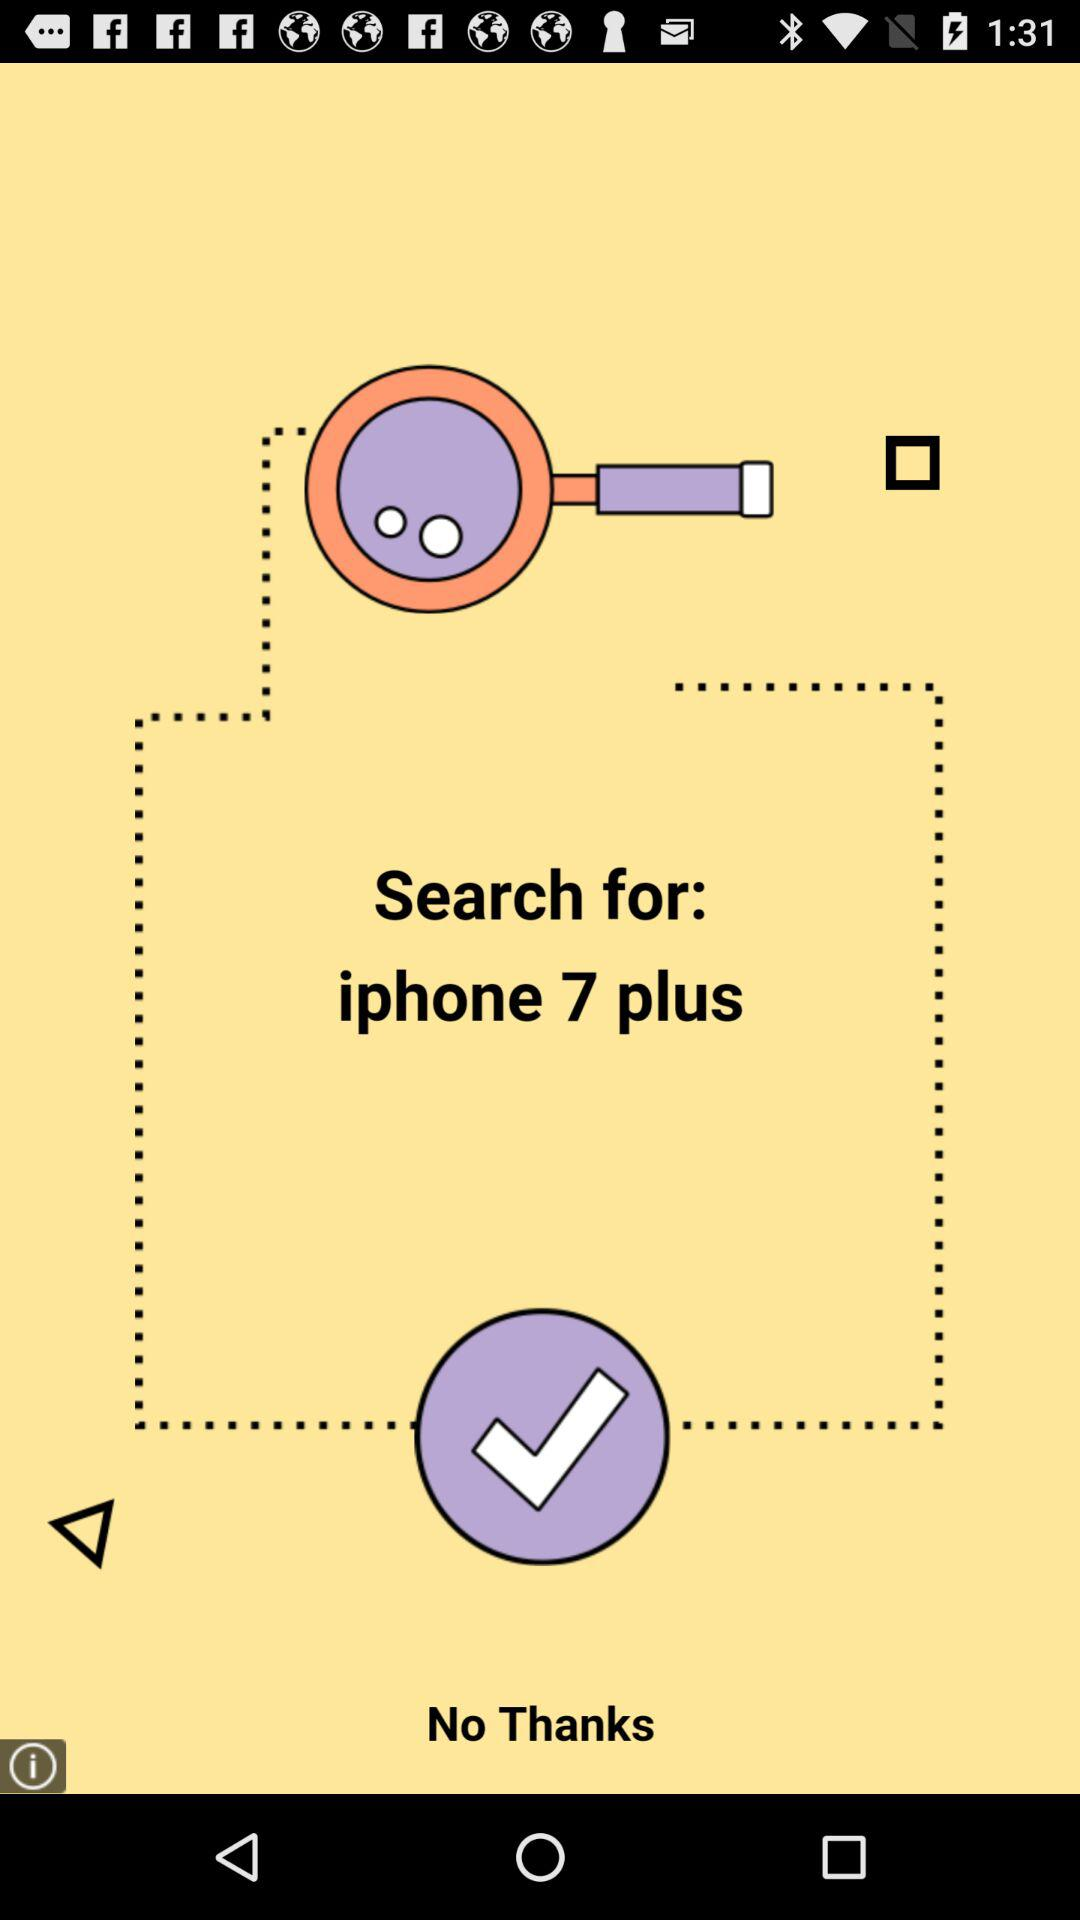For what mobile model is the application searching? The mobile model is "iphone 7 plus". 